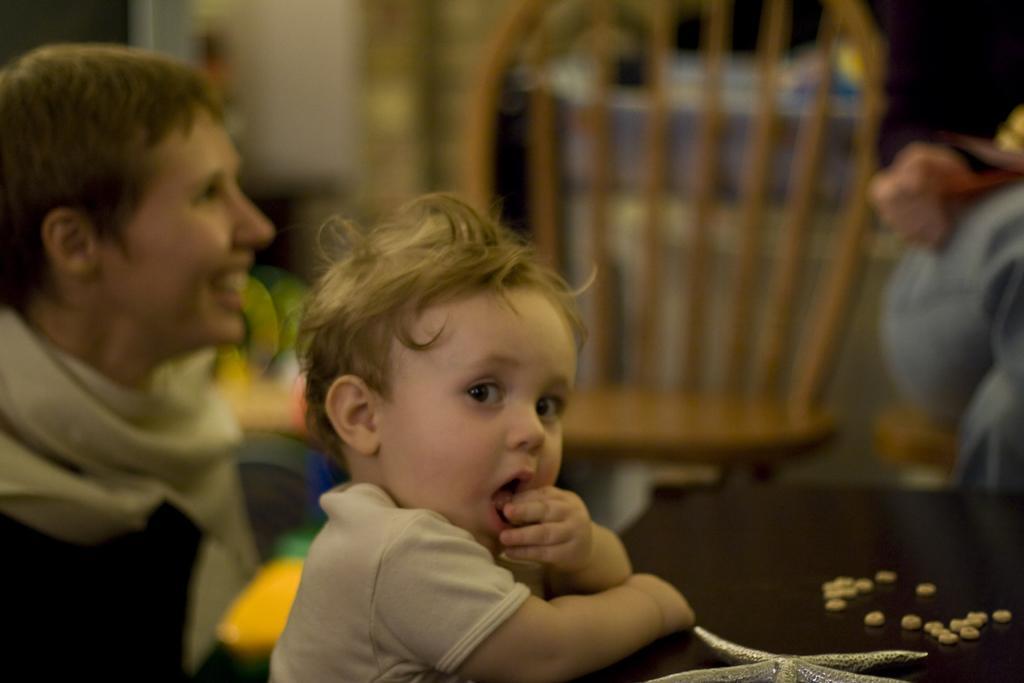How would you summarize this image in a sentence or two? On the left side, there is a baby in white color t-shirt, holding a hand on a table which is covered with a cloth, on which there are some objects. In the background, there is a person who is smiling. And the background is blurred. 